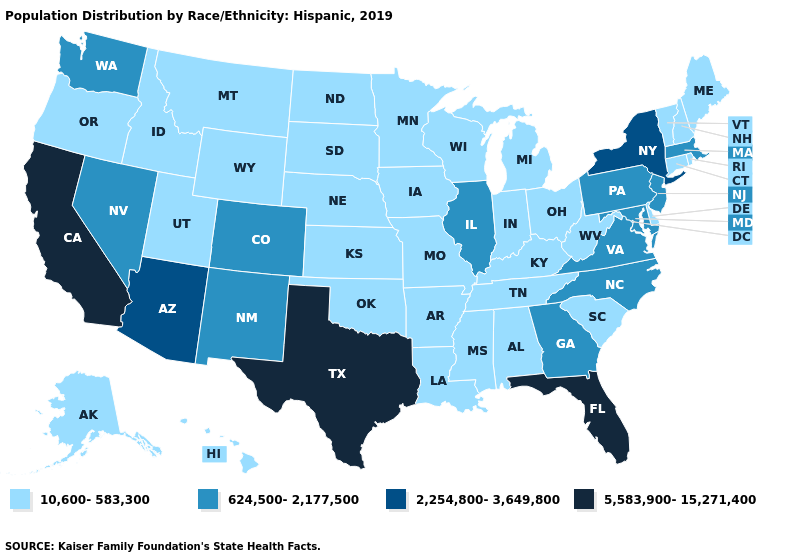Name the states that have a value in the range 2,254,800-3,649,800?
Short answer required. Arizona, New York. Name the states that have a value in the range 2,254,800-3,649,800?
Answer briefly. Arizona, New York. Among the states that border Illinois , which have the lowest value?
Answer briefly. Indiana, Iowa, Kentucky, Missouri, Wisconsin. What is the highest value in the USA?
Short answer required. 5,583,900-15,271,400. Which states have the highest value in the USA?
Answer briefly. California, Florida, Texas. What is the value of Tennessee?
Give a very brief answer. 10,600-583,300. How many symbols are there in the legend?
Short answer required. 4. Among the states that border Nevada , which have the highest value?
Keep it brief. California. Among the states that border Rhode Island , does Connecticut have the highest value?
Keep it brief. No. Does Kentucky have a lower value than North Carolina?
Be succinct. Yes. Among the states that border Indiana , does Illinois have the highest value?
Short answer required. Yes. Does Colorado have the lowest value in the USA?
Keep it brief. No. Which states have the lowest value in the USA?
Keep it brief. Alabama, Alaska, Arkansas, Connecticut, Delaware, Hawaii, Idaho, Indiana, Iowa, Kansas, Kentucky, Louisiana, Maine, Michigan, Minnesota, Mississippi, Missouri, Montana, Nebraska, New Hampshire, North Dakota, Ohio, Oklahoma, Oregon, Rhode Island, South Carolina, South Dakota, Tennessee, Utah, Vermont, West Virginia, Wisconsin, Wyoming. Does Florida have the lowest value in the South?
Give a very brief answer. No. What is the highest value in states that border South Dakota?
Be succinct. 10,600-583,300. 